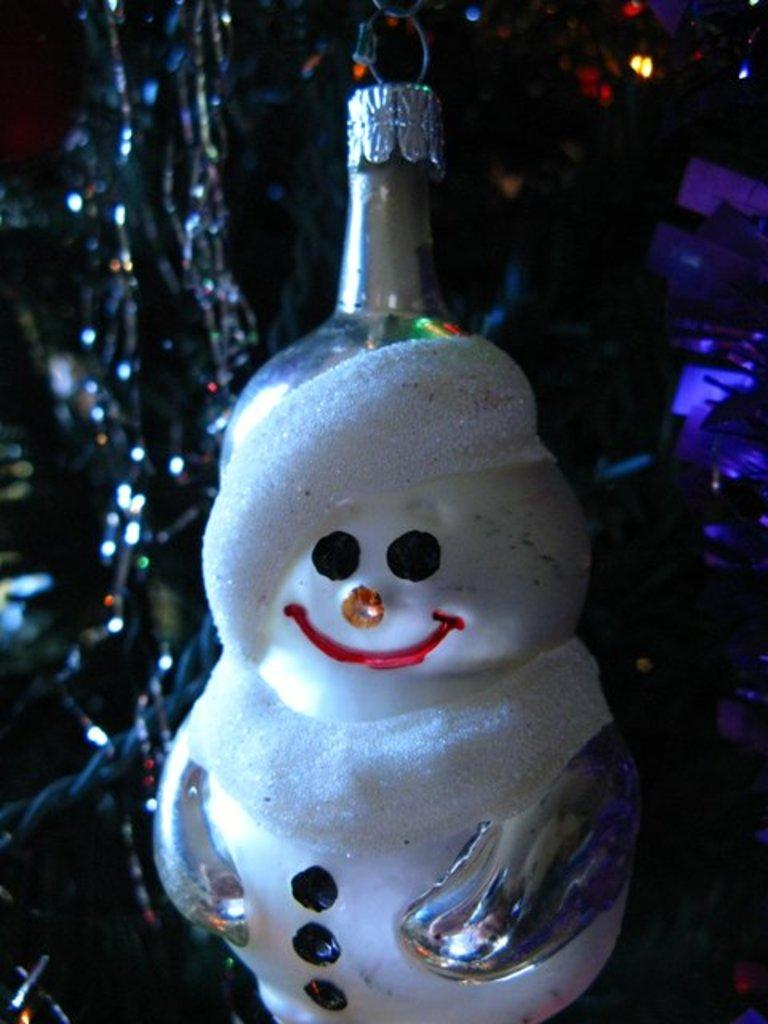What can be seen on the bottle in the image? There is a toy structure on the bottle. What is the main object in the image? The main object in the image is a bottle. What can be observed in the background of the image? Lights are visible in the background of the image, along with other objects. Can you describe the background of the image in more detail? The background of the image is not clear, but it contains lights and other objects. What type of vegetable is growing out of the bottle in the image? There is no vegetable growing out of the bottle in the image; it features a toy structure on the bottle. How is the cork used in the image? There is no cork present in the image. 